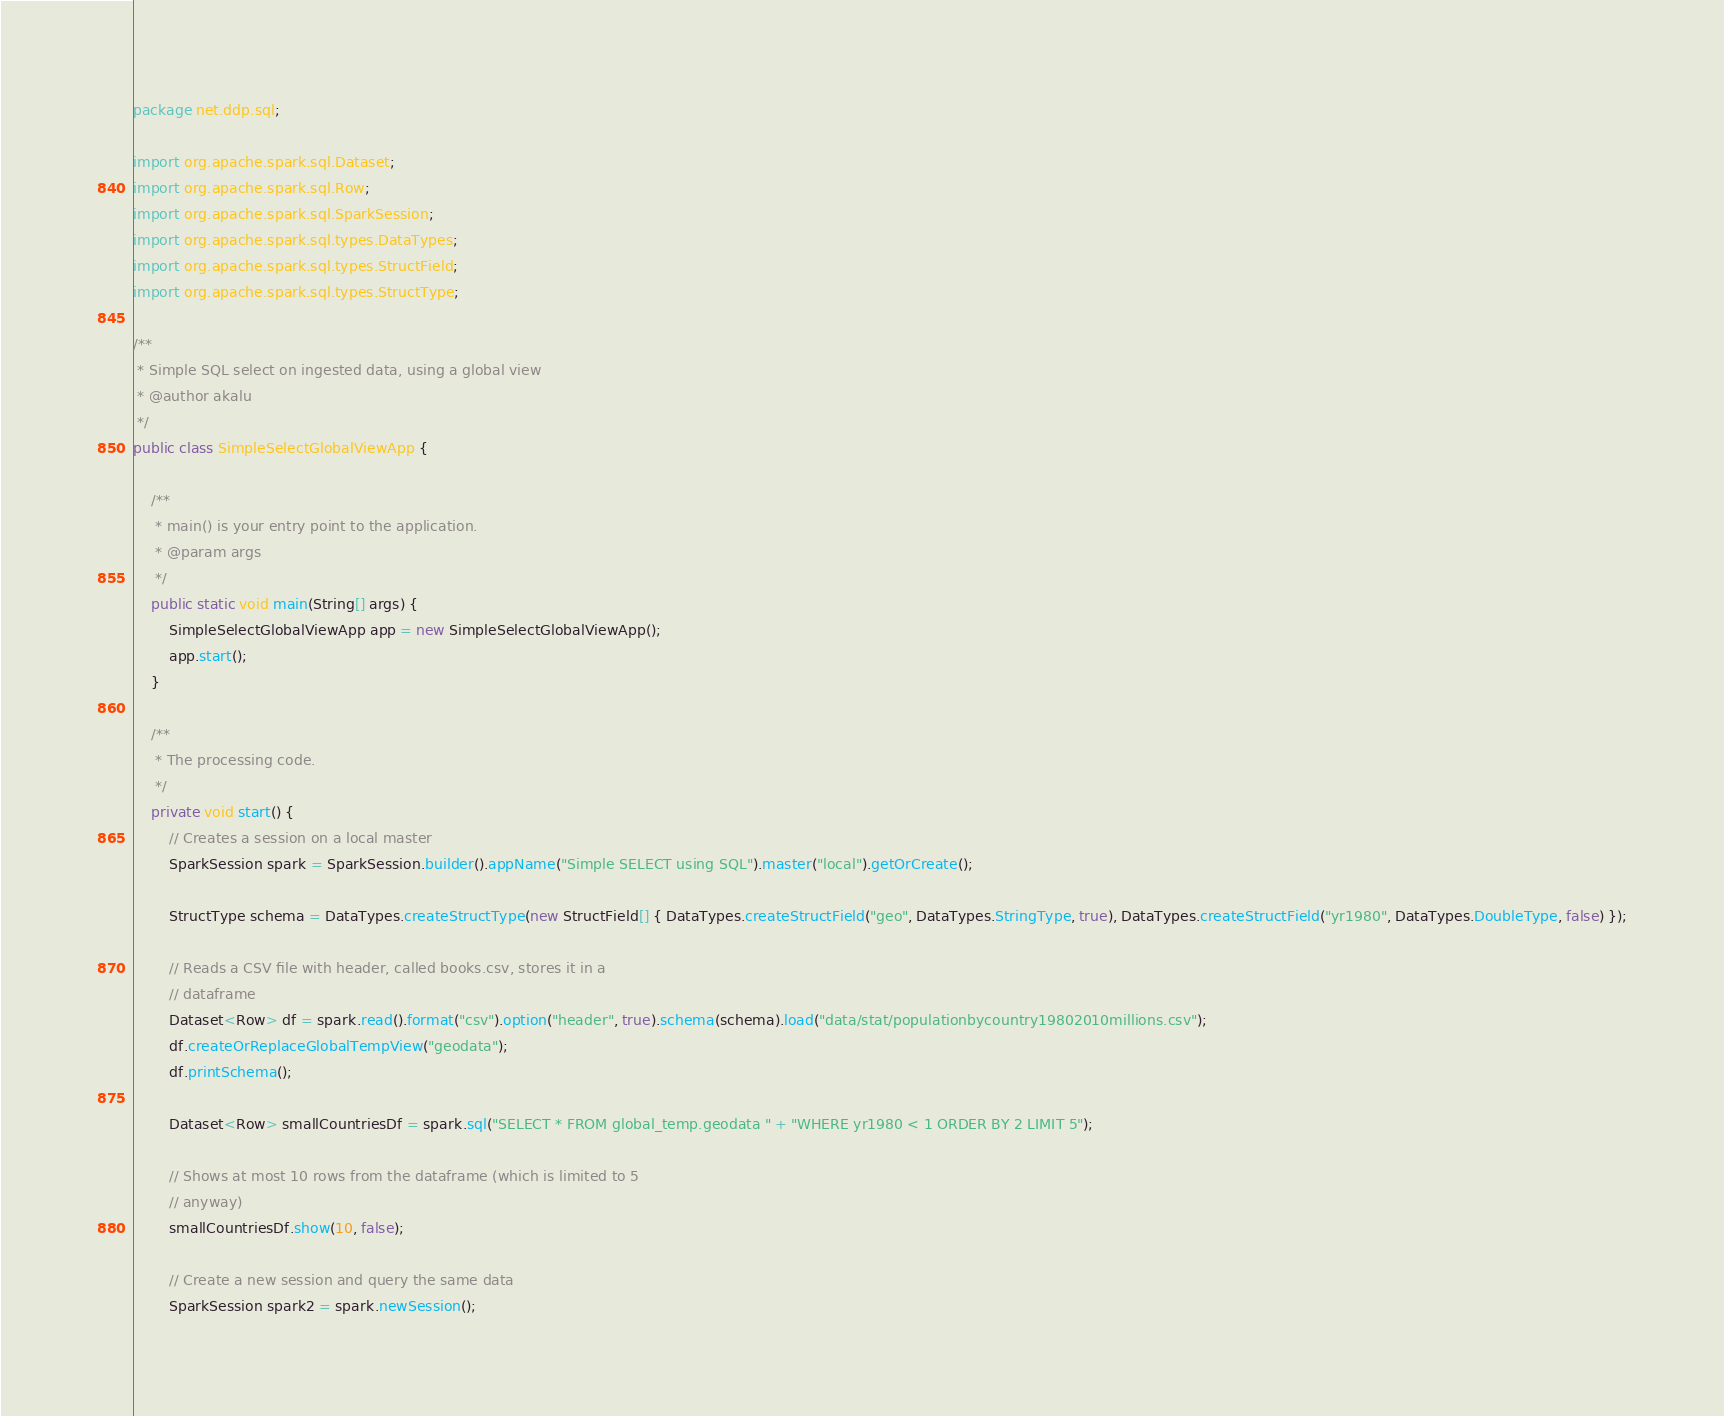Convert code to text. <code><loc_0><loc_0><loc_500><loc_500><_Java_>package net.ddp.sql;

import org.apache.spark.sql.Dataset;
import org.apache.spark.sql.Row;
import org.apache.spark.sql.SparkSession;
import org.apache.spark.sql.types.DataTypes;
import org.apache.spark.sql.types.StructField;
import org.apache.spark.sql.types.StructType;

/**
 * Simple SQL select on ingested data, using a global view
 * @author akalu
 */
public class SimpleSelectGlobalViewApp {

    /**
     * main() is your entry point to the application.
     * @param args
     */
    public static void main(String[] args) {
        SimpleSelectGlobalViewApp app = new SimpleSelectGlobalViewApp();
        app.start();
    }

    /**
     * The processing code.
     */
    private void start() {
        // Creates a session on a local master
        SparkSession spark = SparkSession.builder().appName("Simple SELECT using SQL").master("local").getOrCreate();

        StructType schema = DataTypes.createStructType(new StructField[] { DataTypes.createStructField("geo", DataTypes.StringType, true), DataTypes.createStructField("yr1980", DataTypes.DoubleType, false) });

        // Reads a CSV file with header, called books.csv, stores it in a
        // dataframe
        Dataset<Row> df = spark.read().format("csv").option("header", true).schema(schema).load("data/stat/populationbycountry19802010millions.csv");
        df.createOrReplaceGlobalTempView("geodata");
        df.printSchema();

        Dataset<Row> smallCountriesDf = spark.sql("SELECT * FROM global_temp.geodata " + "WHERE yr1980 < 1 ORDER BY 2 LIMIT 5");

        // Shows at most 10 rows from the dataframe (which is limited to 5
        // anyway)
        smallCountriesDf.show(10, false);

        // Create a new session and query the same data
        SparkSession spark2 = spark.newSession();</code> 